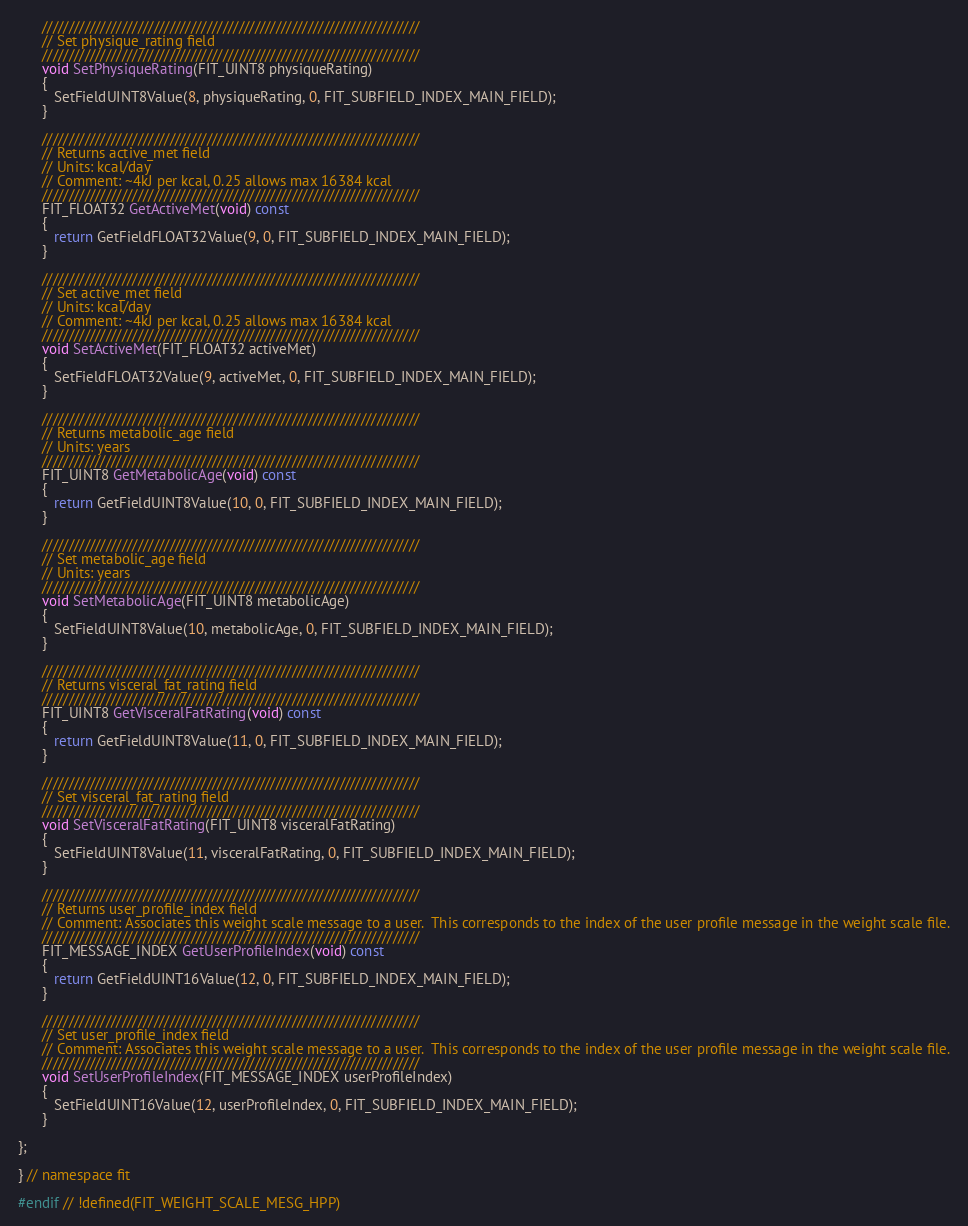Convert code to text. <code><loc_0><loc_0><loc_500><loc_500><_C++_>
      ///////////////////////////////////////////////////////////////////////
      // Set physique_rating field
      ///////////////////////////////////////////////////////////////////////
      void SetPhysiqueRating(FIT_UINT8 physiqueRating)
      {
         SetFieldUINT8Value(8, physiqueRating, 0, FIT_SUBFIELD_INDEX_MAIN_FIELD);
      }

      ///////////////////////////////////////////////////////////////////////
      // Returns active_met field
      // Units: kcal/day
      // Comment: ~4kJ per kcal, 0.25 allows max 16384 kcal
      ///////////////////////////////////////////////////////////////////////
      FIT_FLOAT32 GetActiveMet(void) const
      {
         return GetFieldFLOAT32Value(9, 0, FIT_SUBFIELD_INDEX_MAIN_FIELD);
      }

      ///////////////////////////////////////////////////////////////////////
      // Set active_met field
      // Units: kcal/day
      // Comment: ~4kJ per kcal, 0.25 allows max 16384 kcal
      ///////////////////////////////////////////////////////////////////////
      void SetActiveMet(FIT_FLOAT32 activeMet)
      {
         SetFieldFLOAT32Value(9, activeMet, 0, FIT_SUBFIELD_INDEX_MAIN_FIELD);
      }

      ///////////////////////////////////////////////////////////////////////
      // Returns metabolic_age field
      // Units: years
      ///////////////////////////////////////////////////////////////////////
      FIT_UINT8 GetMetabolicAge(void) const
      {
         return GetFieldUINT8Value(10, 0, FIT_SUBFIELD_INDEX_MAIN_FIELD);
      }

      ///////////////////////////////////////////////////////////////////////
      // Set metabolic_age field
      // Units: years
      ///////////////////////////////////////////////////////////////////////
      void SetMetabolicAge(FIT_UINT8 metabolicAge)
      {
         SetFieldUINT8Value(10, metabolicAge, 0, FIT_SUBFIELD_INDEX_MAIN_FIELD);
      }

      ///////////////////////////////////////////////////////////////////////
      // Returns visceral_fat_rating field
      ///////////////////////////////////////////////////////////////////////
      FIT_UINT8 GetVisceralFatRating(void) const
      {
         return GetFieldUINT8Value(11, 0, FIT_SUBFIELD_INDEX_MAIN_FIELD);
      }

      ///////////////////////////////////////////////////////////////////////
      // Set visceral_fat_rating field
      ///////////////////////////////////////////////////////////////////////
      void SetVisceralFatRating(FIT_UINT8 visceralFatRating)
      {
         SetFieldUINT8Value(11, visceralFatRating, 0, FIT_SUBFIELD_INDEX_MAIN_FIELD);
      }

      ///////////////////////////////////////////////////////////////////////
      // Returns user_profile_index field
      // Comment: Associates this weight scale message to a user.  This corresponds to the index of the user profile message in the weight scale file.
      ///////////////////////////////////////////////////////////////////////
      FIT_MESSAGE_INDEX GetUserProfileIndex(void) const
      {
         return GetFieldUINT16Value(12, 0, FIT_SUBFIELD_INDEX_MAIN_FIELD);
      }

      ///////////////////////////////////////////////////////////////////////
      // Set user_profile_index field
      // Comment: Associates this weight scale message to a user.  This corresponds to the index of the user profile message in the weight scale file.
      ///////////////////////////////////////////////////////////////////////
      void SetUserProfileIndex(FIT_MESSAGE_INDEX userProfileIndex)
      {
         SetFieldUINT16Value(12, userProfileIndex, 0, FIT_SUBFIELD_INDEX_MAIN_FIELD);
      }

};

} // namespace fit

#endif // !defined(FIT_WEIGHT_SCALE_MESG_HPP)
</code> 